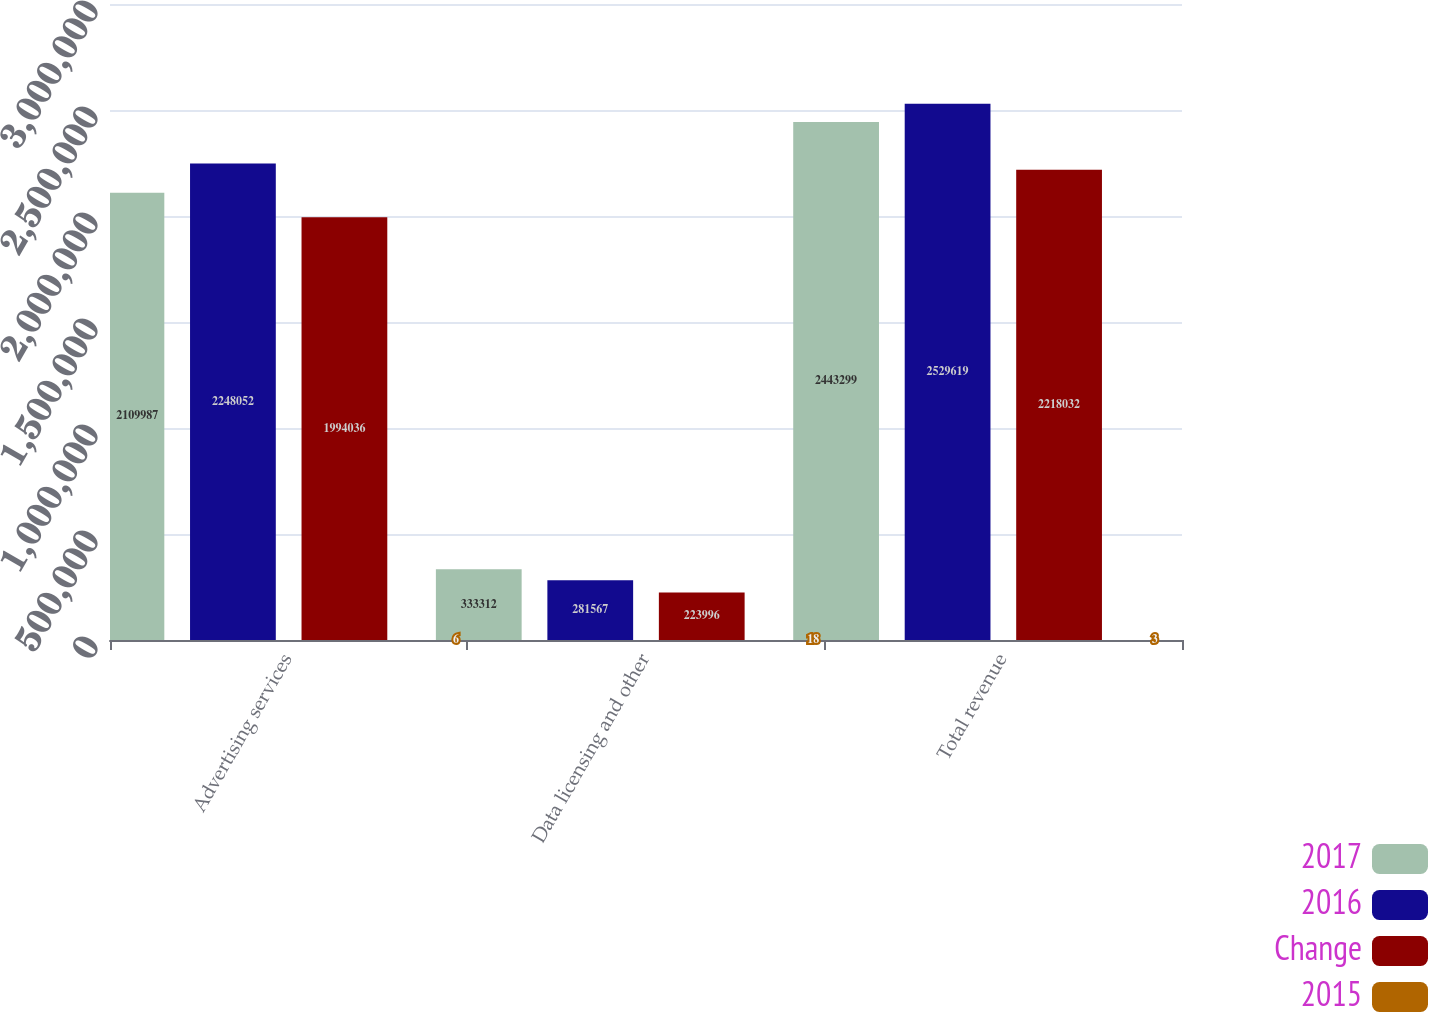Convert chart to OTSL. <chart><loc_0><loc_0><loc_500><loc_500><stacked_bar_chart><ecel><fcel>Advertising services<fcel>Data licensing and other<fcel>Total revenue<nl><fcel>2017<fcel>2.10999e+06<fcel>333312<fcel>2.4433e+06<nl><fcel>2016<fcel>2.24805e+06<fcel>281567<fcel>2.52962e+06<nl><fcel>Change<fcel>1.99404e+06<fcel>223996<fcel>2.21803e+06<nl><fcel>2015<fcel>6<fcel>18<fcel>3<nl></chart> 